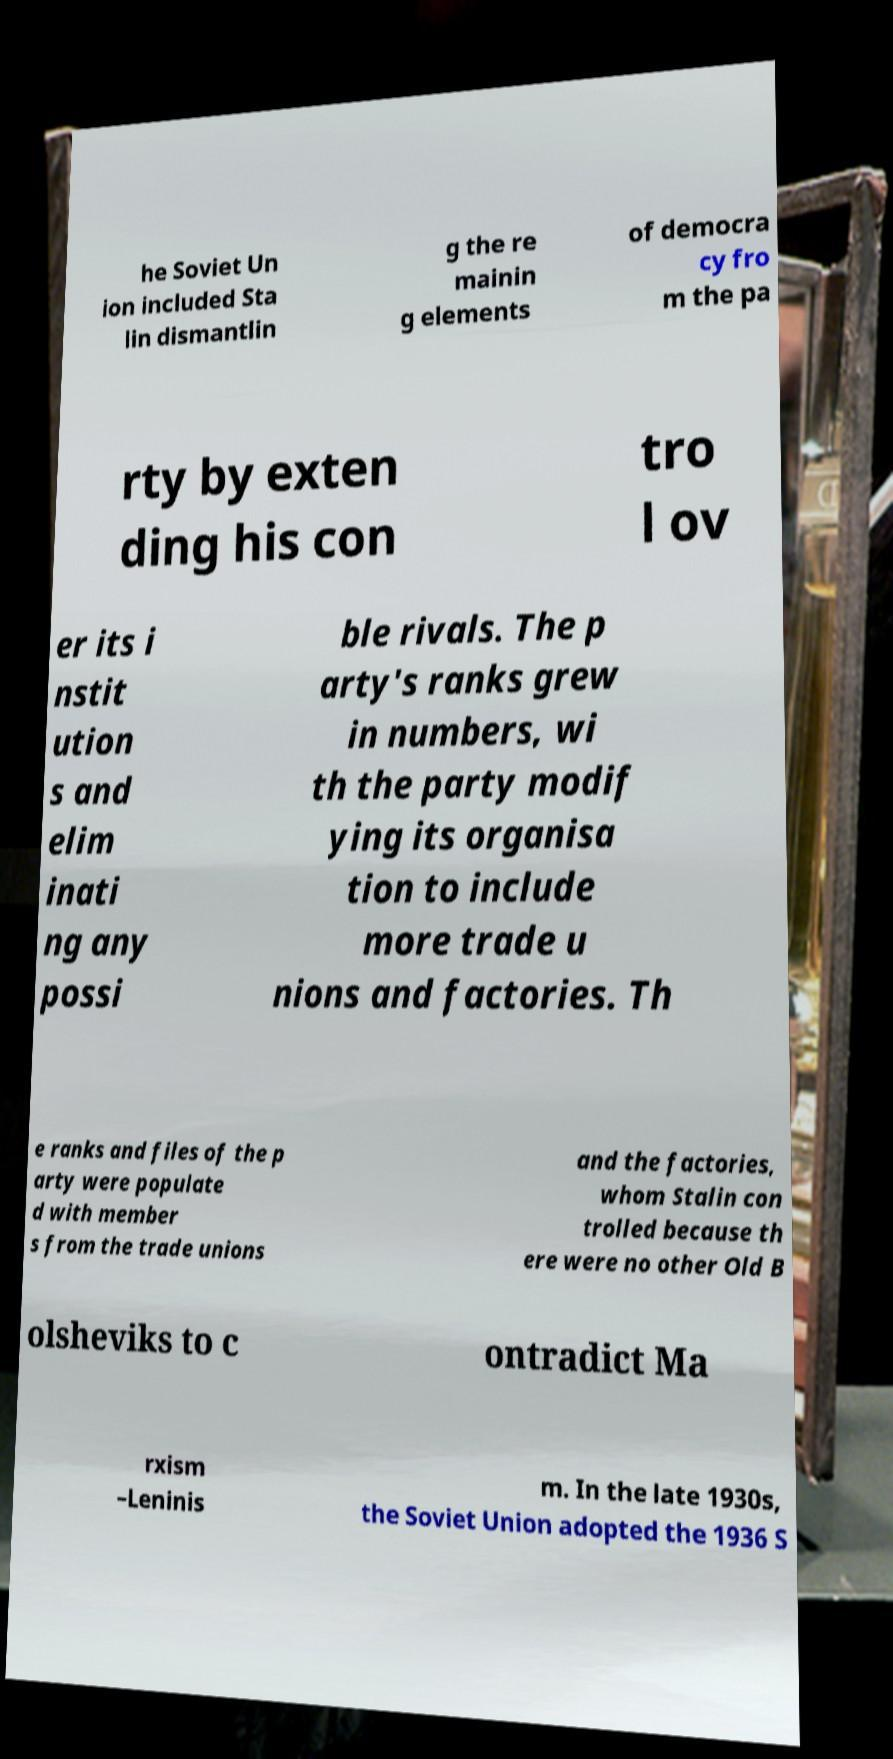Please identify and transcribe the text found in this image. he Soviet Un ion included Sta lin dismantlin g the re mainin g elements of democra cy fro m the pa rty by exten ding his con tro l ov er its i nstit ution s and elim inati ng any possi ble rivals. The p arty's ranks grew in numbers, wi th the party modif ying its organisa tion to include more trade u nions and factories. Th e ranks and files of the p arty were populate d with member s from the trade unions and the factories, whom Stalin con trolled because th ere were no other Old B olsheviks to c ontradict Ma rxism –Leninis m. In the late 1930s, the Soviet Union adopted the 1936 S 